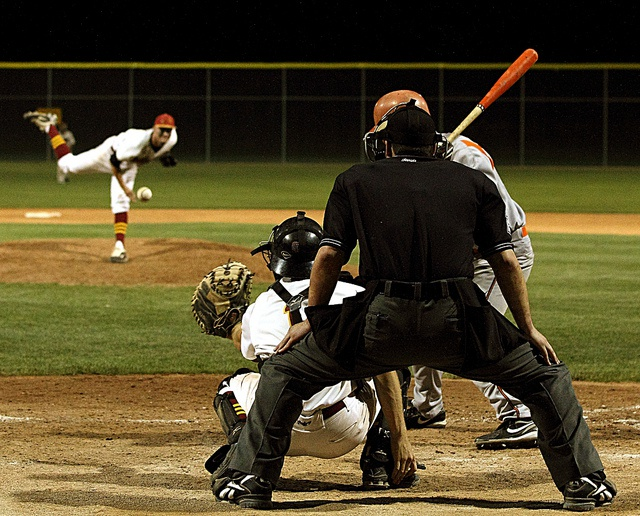Describe the objects in this image and their specific colors. I can see people in black, darkgreen, gray, and tan tones, people in black, white, olive, and maroon tones, people in black, white, olive, and maroon tones, people in black, lightgray, darkgray, and tan tones, and baseball glove in black, olive, and tan tones in this image. 